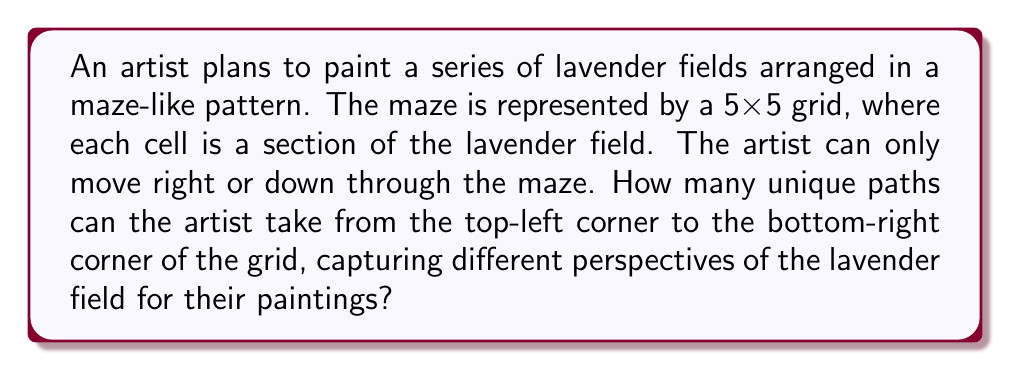What is the answer to this math problem? Let's approach this step-by-step:

1) First, we need to recognize that this is a combinatorics problem, specifically a lattice path problem.

2) To reach the bottom-right corner from the top-left corner, the artist must move:
   - 4 steps right
   - 4 steps down
   (Since it's a 5x5 grid, there are 4 moves in each direction)

3) The total number of steps is always 8 (4 right + 4 down).

4) The question is essentially asking: in how many ways can we arrange 4 right moves and 4 down moves?

5) This is equivalent to choosing the positions for either the right moves or the down moves out of the total 8 positions.

6) We can solve this using the combination formula:

   $$\binom{8}{4} = \frac{8!}{4!(8-4)!} = \frac{8!}{4!4!}$$

7) Let's calculate this:
   $$\frac{8 * 7 * 6 * 5 * 4!}{4! * 4 * 3 * 2 * 1}$$

8) The 4! cancels out in the numerator and denominator:
   $$\frac{8 * 7 * 6 * 5}{4 * 3 * 2 * 1} = \frac{1680}{24} = 70$$

Therefore, there are 70 unique paths through the lavender field maze.
Answer: 70 